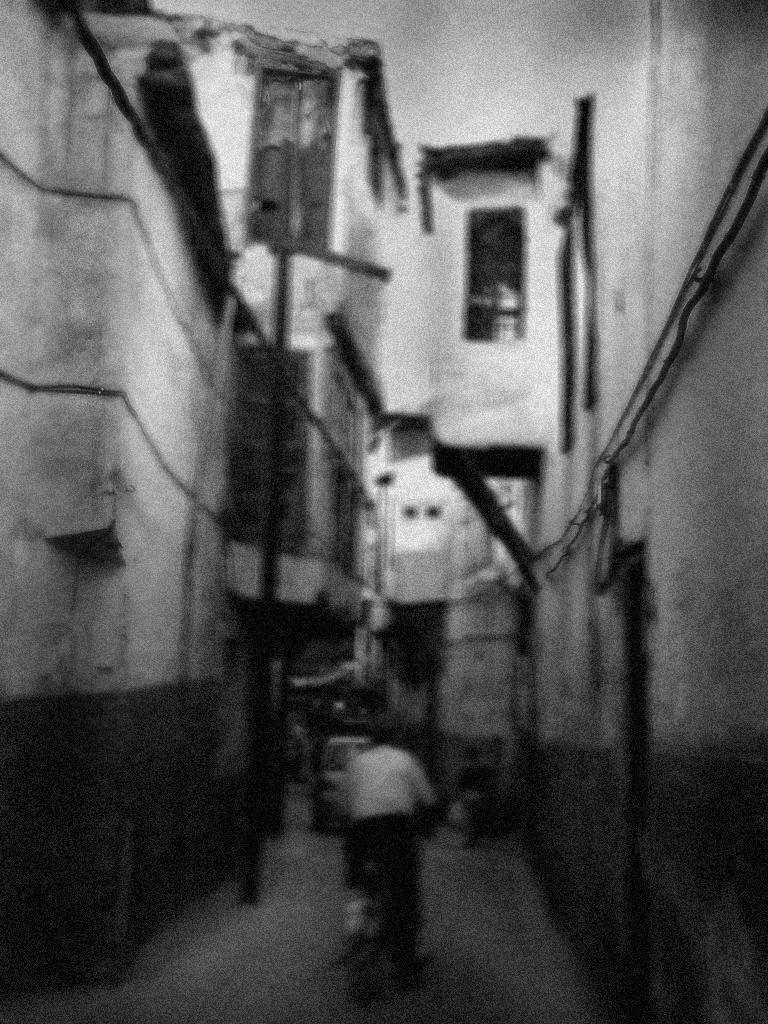How would you summarize this image in a sentence or two? It is a blur image. In this image, we can see few houses, walls, poles, vehicle. At the bottom, we can see a person is riding a vehicle on the path. Top of the image, there is a sky. 